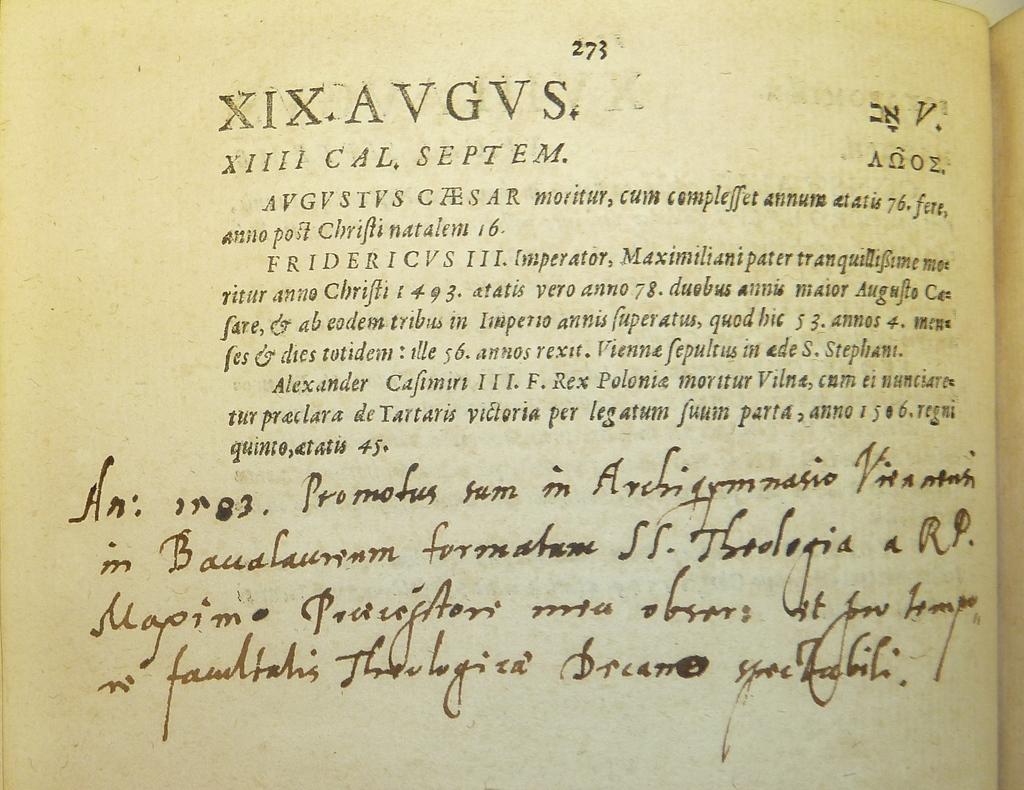What page number is this page?
Provide a short and direct response. 273. What is the title?
Provide a succinct answer. Unanswerable. 